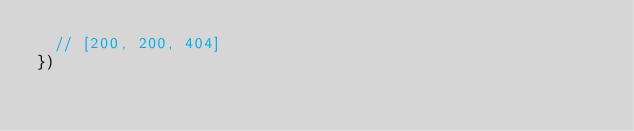<code> <loc_0><loc_0><loc_500><loc_500><_JavaScript_>  // [200, 200, 404]
})
</code> 